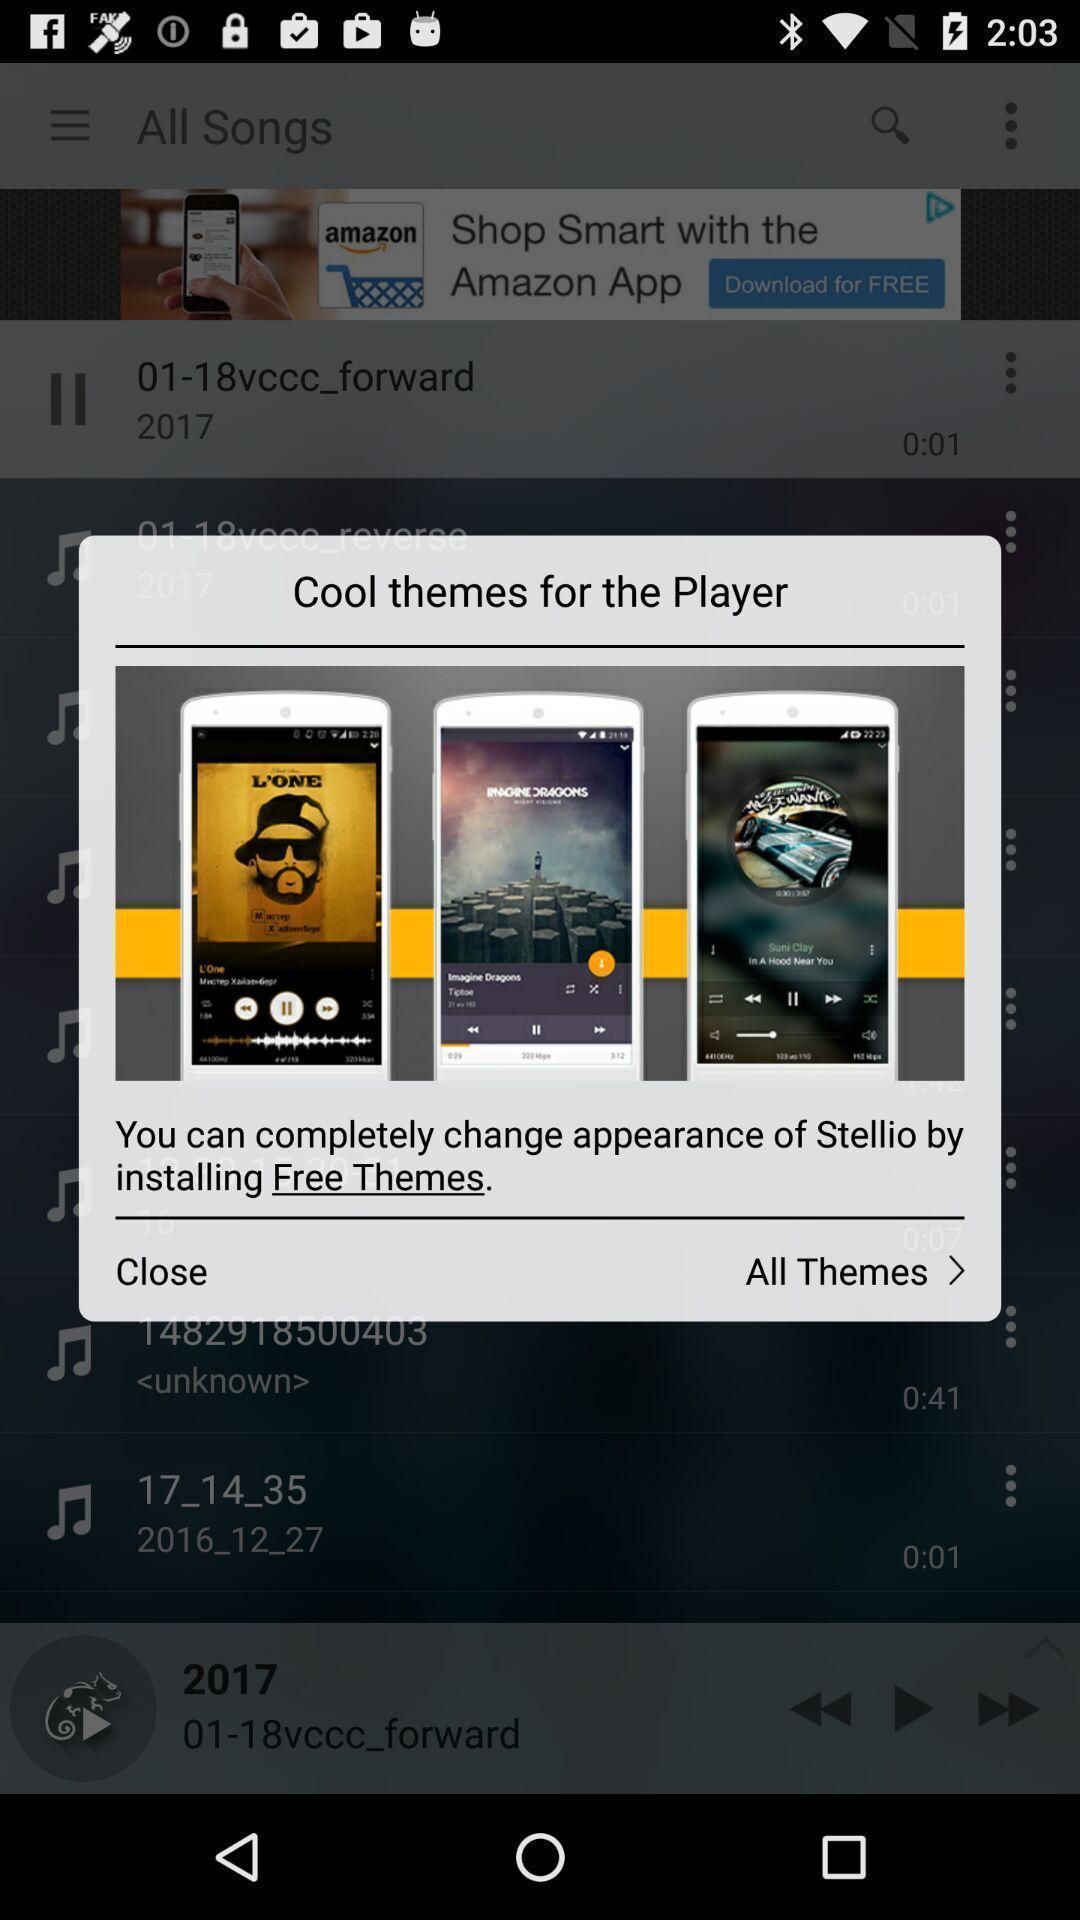Provide a detailed account of this screenshot. Pop-up window showing a theme app. 